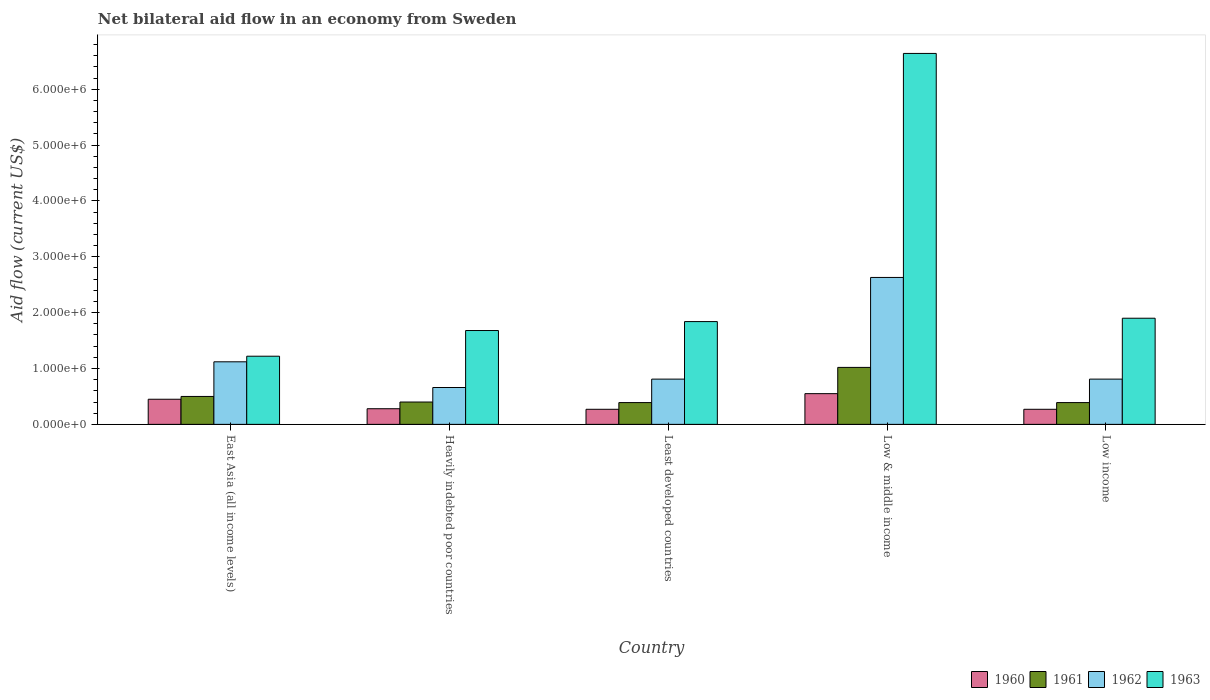How many different coloured bars are there?
Your answer should be very brief. 4. Are the number of bars on each tick of the X-axis equal?
Give a very brief answer. Yes. How many bars are there on the 1st tick from the right?
Your answer should be very brief. 4. What is the label of the 2nd group of bars from the left?
Your answer should be very brief. Heavily indebted poor countries. Across all countries, what is the maximum net bilateral aid flow in 1961?
Your answer should be compact. 1.02e+06. In which country was the net bilateral aid flow in 1962 maximum?
Ensure brevity in your answer.  Low & middle income. In which country was the net bilateral aid flow in 1961 minimum?
Provide a succinct answer. Least developed countries. What is the total net bilateral aid flow in 1963 in the graph?
Ensure brevity in your answer.  1.33e+07. What is the difference between the net bilateral aid flow in 1962 in Heavily indebted poor countries and the net bilateral aid flow in 1961 in Low & middle income?
Your answer should be very brief. -3.60e+05. What is the average net bilateral aid flow in 1961 per country?
Give a very brief answer. 5.40e+05. What is the difference between the net bilateral aid flow of/in 1963 and net bilateral aid flow of/in 1962 in East Asia (all income levels)?
Keep it short and to the point. 1.00e+05. In how many countries, is the net bilateral aid flow in 1961 greater than 2600000 US$?
Keep it short and to the point. 0. What is the ratio of the net bilateral aid flow in 1960 in Least developed countries to that in Low income?
Your answer should be compact. 1. Is the net bilateral aid flow in 1963 in Low & middle income less than that in Low income?
Make the answer very short. No. Is the difference between the net bilateral aid flow in 1963 in East Asia (all income levels) and Low income greater than the difference between the net bilateral aid flow in 1962 in East Asia (all income levels) and Low income?
Ensure brevity in your answer.  No. What is the difference between the highest and the lowest net bilateral aid flow in 1960?
Keep it short and to the point. 2.80e+05. In how many countries, is the net bilateral aid flow in 1963 greater than the average net bilateral aid flow in 1963 taken over all countries?
Provide a succinct answer. 1. Is it the case that in every country, the sum of the net bilateral aid flow in 1960 and net bilateral aid flow in 1961 is greater than the sum of net bilateral aid flow in 1962 and net bilateral aid flow in 1963?
Provide a succinct answer. No. What does the 4th bar from the left in Least developed countries represents?
Ensure brevity in your answer.  1963. What does the 3rd bar from the right in East Asia (all income levels) represents?
Your response must be concise. 1961. Is it the case that in every country, the sum of the net bilateral aid flow in 1962 and net bilateral aid flow in 1960 is greater than the net bilateral aid flow in 1961?
Keep it short and to the point. Yes. Are all the bars in the graph horizontal?
Offer a terse response. No. How many countries are there in the graph?
Keep it short and to the point. 5. Does the graph contain any zero values?
Your answer should be very brief. No. Does the graph contain grids?
Make the answer very short. No. Where does the legend appear in the graph?
Your answer should be very brief. Bottom right. How many legend labels are there?
Make the answer very short. 4. How are the legend labels stacked?
Your answer should be very brief. Horizontal. What is the title of the graph?
Keep it short and to the point. Net bilateral aid flow in an economy from Sweden. What is the label or title of the X-axis?
Give a very brief answer. Country. What is the Aid flow (current US$) in 1960 in East Asia (all income levels)?
Provide a short and direct response. 4.50e+05. What is the Aid flow (current US$) of 1962 in East Asia (all income levels)?
Your response must be concise. 1.12e+06. What is the Aid flow (current US$) of 1963 in East Asia (all income levels)?
Provide a short and direct response. 1.22e+06. What is the Aid flow (current US$) in 1960 in Heavily indebted poor countries?
Make the answer very short. 2.80e+05. What is the Aid flow (current US$) of 1962 in Heavily indebted poor countries?
Your answer should be very brief. 6.60e+05. What is the Aid flow (current US$) of 1963 in Heavily indebted poor countries?
Make the answer very short. 1.68e+06. What is the Aid flow (current US$) of 1960 in Least developed countries?
Give a very brief answer. 2.70e+05. What is the Aid flow (current US$) of 1961 in Least developed countries?
Provide a succinct answer. 3.90e+05. What is the Aid flow (current US$) in 1962 in Least developed countries?
Provide a succinct answer. 8.10e+05. What is the Aid flow (current US$) of 1963 in Least developed countries?
Ensure brevity in your answer.  1.84e+06. What is the Aid flow (current US$) in 1961 in Low & middle income?
Give a very brief answer. 1.02e+06. What is the Aid flow (current US$) in 1962 in Low & middle income?
Make the answer very short. 2.63e+06. What is the Aid flow (current US$) of 1963 in Low & middle income?
Provide a short and direct response. 6.64e+06. What is the Aid flow (current US$) of 1961 in Low income?
Offer a very short reply. 3.90e+05. What is the Aid flow (current US$) of 1962 in Low income?
Your response must be concise. 8.10e+05. What is the Aid flow (current US$) of 1963 in Low income?
Give a very brief answer. 1.90e+06. Across all countries, what is the maximum Aid flow (current US$) in 1960?
Keep it short and to the point. 5.50e+05. Across all countries, what is the maximum Aid flow (current US$) in 1961?
Keep it short and to the point. 1.02e+06. Across all countries, what is the maximum Aid flow (current US$) in 1962?
Keep it short and to the point. 2.63e+06. Across all countries, what is the maximum Aid flow (current US$) of 1963?
Your response must be concise. 6.64e+06. Across all countries, what is the minimum Aid flow (current US$) of 1960?
Your response must be concise. 2.70e+05. Across all countries, what is the minimum Aid flow (current US$) of 1962?
Your answer should be very brief. 6.60e+05. Across all countries, what is the minimum Aid flow (current US$) of 1963?
Give a very brief answer. 1.22e+06. What is the total Aid flow (current US$) in 1960 in the graph?
Provide a succinct answer. 1.82e+06. What is the total Aid flow (current US$) of 1961 in the graph?
Provide a short and direct response. 2.70e+06. What is the total Aid flow (current US$) in 1962 in the graph?
Your answer should be very brief. 6.03e+06. What is the total Aid flow (current US$) in 1963 in the graph?
Your answer should be very brief. 1.33e+07. What is the difference between the Aid flow (current US$) of 1960 in East Asia (all income levels) and that in Heavily indebted poor countries?
Provide a short and direct response. 1.70e+05. What is the difference between the Aid flow (current US$) in 1963 in East Asia (all income levels) and that in Heavily indebted poor countries?
Provide a short and direct response. -4.60e+05. What is the difference between the Aid flow (current US$) in 1960 in East Asia (all income levels) and that in Least developed countries?
Your response must be concise. 1.80e+05. What is the difference between the Aid flow (current US$) in 1963 in East Asia (all income levels) and that in Least developed countries?
Provide a succinct answer. -6.20e+05. What is the difference between the Aid flow (current US$) of 1960 in East Asia (all income levels) and that in Low & middle income?
Keep it short and to the point. -1.00e+05. What is the difference between the Aid flow (current US$) of 1961 in East Asia (all income levels) and that in Low & middle income?
Your answer should be very brief. -5.20e+05. What is the difference between the Aid flow (current US$) of 1962 in East Asia (all income levels) and that in Low & middle income?
Offer a very short reply. -1.51e+06. What is the difference between the Aid flow (current US$) in 1963 in East Asia (all income levels) and that in Low & middle income?
Provide a succinct answer. -5.42e+06. What is the difference between the Aid flow (current US$) in 1963 in East Asia (all income levels) and that in Low income?
Offer a terse response. -6.80e+05. What is the difference between the Aid flow (current US$) in 1960 in Heavily indebted poor countries and that in Least developed countries?
Make the answer very short. 10000. What is the difference between the Aid flow (current US$) in 1962 in Heavily indebted poor countries and that in Least developed countries?
Give a very brief answer. -1.50e+05. What is the difference between the Aid flow (current US$) in 1961 in Heavily indebted poor countries and that in Low & middle income?
Ensure brevity in your answer.  -6.20e+05. What is the difference between the Aid flow (current US$) of 1962 in Heavily indebted poor countries and that in Low & middle income?
Keep it short and to the point. -1.97e+06. What is the difference between the Aid flow (current US$) in 1963 in Heavily indebted poor countries and that in Low & middle income?
Ensure brevity in your answer.  -4.96e+06. What is the difference between the Aid flow (current US$) in 1960 in Heavily indebted poor countries and that in Low income?
Offer a terse response. 10000. What is the difference between the Aid flow (current US$) of 1960 in Least developed countries and that in Low & middle income?
Keep it short and to the point. -2.80e+05. What is the difference between the Aid flow (current US$) in 1961 in Least developed countries and that in Low & middle income?
Ensure brevity in your answer.  -6.30e+05. What is the difference between the Aid flow (current US$) in 1962 in Least developed countries and that in Low & middle income?
Provide a short and direct response. -1.82e+06. What is the difference between the Aid flow (current US$) of 1963 in Least developed countries and that in Low & middle income?
Offer a terse response. -4.80e+06. What is the difference between the Aid flow (current US$) of 1962 in Least developed countries and that in Low income?
Provide a succinct answer. 0. What is the difference between the Aid flow (current US$) of 1960 in Low & middle income and that in Low income?
Your response must be concise. 2.80e+05. What is the difference between the Aid flow (current US$) of 1961 in Low & middle income and that in Low income?
Your response must be concise. 6.30e+05. What is the difference between the Aid flow (current US$) of 1962 in Low & middle income and that in Low income?
Give a very brief answer. 1.82e+06. What is the difference between the Aid flow (current US$) of 1963 in Low & middle income and that in Low income?
Your response must be concise. 4.74e+06. What is the difference between the Aid flow (current US$) in 1960 in East Asia (all income levels) and the Aid flow (current US$) in 1963 in Heavily indebted poor countries?
Your answer should be compact. -1.23e+06. What is the difference between the Aid flow (current US$) of 1961 in East Asia (all income levels) and the Aid flow (current US$) of 1963 in Heavily indebted poor countries?
Keep it short and to the point. -1.18e+06. What is the difference between the Aid flow (current US$) in 1962 in East Asia (all income levels) and the Aid flow (current US$) in 1963 in Heavily indebted poor countries?
Give a very brief answer. -5.60e+05. What is the difference between the Aid flow (current US$) of 1960 in East Asia (all income levels) and the Aid flow (current US$) of 1961 in Least developed countries?
Your answer should be compact. 6.00e+04. What is the difference between the Aid flow (current US$) of 1960 in East Asia (all income levels) and the Aid flow (current US$) of 1962 in Least developed countries?
Your answer should be compact. -3.60e+05. What is the difference between the Aid flow (current US$) of 1960 in East Asia (all income levels) and the Aid flow (current US$) of 1963 in Least developed countries?
Provide a succinct answer. -1.39e+06. What is the difference between the Aid flow (current US$) in 1961 in East Asia (all income levels) and the Aid flow (current US$) in 1962 in Least developed countries?
Offer a very short reply. -3.10e+05. What is the difference between the Aid flow (current US$) in 1961 in East Asia (all income levels) and the Aid flow (current US$) in 1963 in Least developed countries?
Offer a very short reply. -1.34e+06. What is the difference between the Aid flow (current US$) in 1962 in East Asia (all income levels) and the Aid flow (current US$) in 1963 in Least developed countries?
Keep it short and to the point. -7.20e+05. What is the difference between the Aid flow (current US$) of 1960 in East Asia (all income levels) and the Aid flow (current US$) of 1961 in Low & middle income?
Make the answer very short. -5.70e+05. What is the difference between the Aid flow (current US$) in 1960 in East Asia (all income levels) and the Aid flow (current US$) in 1962 in Low & middle income?
Provide a succinct answer. -2.18e+06. What is the difference between the Aid flow (current US$) of 1960 in East Asia (all income levels) and the Aid flow (current US$) of 1963 in Low & middle income?
Offer a terse response. -6.19e+06. What is the difference between the Aid flow (current US$) in 1961 in East Asia (all income levels) and the Aid flow (current US$) in 1962 in Low & middle income?
Your response must be concise. -2.13e+06. What is the difference between the Aid flow (current US$) in 1961 in East Asia (all income levels) and the Aid flow (current US$) in 1963 in Low & middle income?
Give a very brief answer. -6.14e+06. What is the difference between the Aid flow (current US$) in 1962 in East Asia (all income levels) and the Aid flow (current US$) in 1963 in Low & middle income?
Your response must be concise. -5.52e+06. What is the difference between the Aid flow (current US$) of 1960 in East Asia (all income levels) and the Aid flow (current US$) of 1961 in Low income?
Make the answer very short. 6.00e+04. What is the difference between the Aid flow (current US$) in 1960 in East Asia (all income levels) and the Aid flow (current US$) in 1962 in Low income?
Give a very brief answer. -3.60e+05. What is the difference between the Aid flow (current US$) of 1960 in East Asia (all income levels) and the Aid flow (current US$) of 1963 in Low income?
Offer a very short reply. -1.45e+06. What is the difference between the Aid flow (current US$) of 1961 in East Asia (all income levels) and the Aid flow (current US$) of 1962 in Low income?
Provide a short and direct response. -3.10e+05. What is the difference between the Aid flow (current US$) in 1961 in East Asia (all income levels) and the Aid flow (current US$) in 1963 in Low income?
Provide a short and direct response. -1.40e+06. What is the difference between the Aid flow (current US$) of 1962 in East Asia (all income levels) and the Aid flow (current US$) of 1963 in Low income?
Your response must be concise. -7.80e+05. What is the difference between the Aid flow (current US$) of 1960 in Heavily indebted poor countries and the Aid flow (current US$) of 1961 in Least developed countries?
Your answer should be very brief. -1.10e+05. What is the difference between the Aid flow (current US$) of 1960 in Heavily indebted poor countries and the Aid flow (current US$) of 1962 in Least developed countries?
Your answer should be very brief. -5.30e+05. What is the difference between the Aid flow (current US$) of 1960 in Heavily indebted poor countries and the Aid flow (current US$) of 1963 in Least developed countries?
Provide a short and direct response. -1.56e+06. What is the difference between the Aid flow (current US$) of 1961 in Heavily indebted poor countries and the Aid flow (current US$) of 1962 in Least developed countries?
Ensure brevity in your answer.  -4.10e+05. What is the difference between the Aid flow (current US$) of 1961 in Heavily indebted poor countries and the Aid flow (current US$) of 1963 in Least developed countries?
Provide a short and direct response. -1.44e+06. What is the difference between the Aid flow (current US$) in 1962 in Heavily indebted poor countries and the Aid flow (current US$) in 1963 in Least developed countries?
Make the answer very short. -1.18e+06. What is the difference between the Aid flow (current US$) in 1960 in Heavily indebted poor countries and the Aid flow (current US$) in 1961 in Low & middle income?
Offer a very short reply. -7.40e+05. What is the difference between the Aid flow (current US$) in 1960 in Heavily indebted poor countries and the Aid flow (current US$) in 1962 in Low & middle income?
Give a very brief answer. -2.35e+06. What is the difference between the Aid flow (current US$) in 1960 in Heavily indebted poor countries and the Aid flow (current US$) in 1963 in Low & middle income?
Ensure brevity in your answer.  -6.36e+06. What is the difference between the Aid flow (current US$) of 1961 in Heavily indebted poor countries and the Aid flow (current US$) of 1962 in Low & middle income?
Offer a terse response. -2.23e+06. What is the difference between the Aid flow (current US$) of 1961 in Heavily indebted poor countries and the Aid flow (current US$) of 1963 in Low & middle income?
Ensure brevity in your answer.  -6.24e+06. What is the difference between the Aid flow (current US$) of 1962 in Heavily indebted poor countries and the Aid flow (current US$) of 1963 in Low & middle income?
Your answer should be very brief. -5.98e+06. What is the difference between the Aid flow (current US$) of 1960 in Heavily indebted poor countries and the Aid flow (current US$) of 1962 in Low income?
Your answer should be very brief. -5.30e+05. What is the difference between the Aid flow (current US$) of 1960 in Heavily indebted poor countries and the Aid flow (current US$) of 1963 in Low income?
Provide a succinct answer. -1.62e+06. What is the difference between the Aid flow (current US$) of 1961 in Heavily indebted poor countries and the Aid flow (current US$) of 1962 in Low income?
Give a very brief answer. -4.10e+05. What is the difference between the Aid flow (current US$) in 1961 in Heavily indebted poor countries and the Aid flow (current US$) in 1963 in Low income?
Offer a very short reply. -1.50e+06. What is the difference between the Aid flow (current US$) in 1962 in Heavily indebted poor countries and the Aid flow (current US$) in 1963 in Low income?
Your response must be concise. -1.24e+06. What is the difference between the Aid flow (current US$) of 1960 in Least developed countries and the Aid flow (current US$) of 1961 in Low & middle income?
Provide a succinct answer. -7.50e+05. What is the difference between the Aid flow (current US$) in 1960 in Least developed countries and the Aid flow (current US$) in 1962 in Low & middle income?
Your response must be concise. -2.36e+06. What is the difference between the Aid flow (current US$) in 1960 in Least developed countries and the Aid flow (current US$) in 1963 in Low & middle income?
Your response must be concise. -6.37e+06. What is the difference between the Aid flow (current US$) of 1961 in Least developed countries and the Aid flow (current US$) of 1962 in Low & middle income?
Ensure brevity in your answer.  -2.24e+06. What is the difference between the Aid flow (current US$) of 1961 in Least developed countries and the Aid flow (current US$) of 1963 in Low & middle income?
Your answer should be very brief. -6.25e+06. What is the difference between the Aid flow (current US$) in 1962 in Least developed countries and the Aid flow (current US$) in 1963 in Low & middle income?
Provide a succinct answer. -5.83e+06. What is the difference between the Aid flow (current US$) in 1960 in Least developed countries and the Aid flow (current US$) in 1961 in Low income?
Make the answer very short. -1.20e+05. What is the difference between the Aid flow (current US$) of 1960 in Least developed countries and the Aid flow (current US$) of 1962 in Low income?
Your response must be concise. -5.40e+05. What is the difference between the Aid flow (current US$) in 1960 in Least developed countries and the Aid flow (current US$) in 1963 in Low income?
Ensure brevity in your answer.  -1.63e+06. What is the difference between the Aid flow (current US$) of 1961 in Least developed countries and the Aid flow (current US$) of 1962 in Low income?
Your response must be concise. -4.20e+05. What is the difference between the Aid flow (current US$) in 1961 in Least developed countries and the Aid flow (current US$) in 1963 in Low income?
Your response must be concise. -1.51e+06. What is the difference between the Aid flow (current US$) in 1962 in Least developed countries and the Aid flow (current US$) in 1963 in Low income?
Offer a terse response. -1.09e+06. What is the difference between the Aid flow (current US$) in 1960 in Low & middle income and the Aid flow (current US$) in 1961 in Low income?
Offer a very short reply. 1.60e+05. What is the difference between the Aid flow (current US$) of 1960 in Low & middle income and the Aid flow (current US$) of 1962 in Low income?
Keep it short and to the point. -2.60e+05. What is the difference between the Aid flow (current US$) in 1960 in Low & middle income and the Aid flow (current US$) in 1963 in Low income?
Provide a succinct answer. -1.35e+06. What is the difference between the Aid flow (current US$) of 1961 in Low & middle income and the Aid flow (current US$) of 1962 in Low income?
Give a very brief answer. 2.10e+05. What is the difference between the Aid flow (current US$) in 1961 in Low & middle income and the Aid flow (current US$) in 1963 in Low income?
Your response must be concise. -8.80e+05. What is the difference between the Aid flow (current US$) in 1962 in Low & middle income and the Aid flow (current US$) in 1963 in Low income?
Ensure brevity in your answer.  7.30e+05. What is the average Aid flow (current US$) in 1960 per country?
Ensure brevity in your answer.  3.64e+05. What is the average Aid flow (current US$) in 1961 per country?
Offer a very short reply. 5.40e+05. What is the average Aid flow (current US$) of 1962 per country?
Keep it short and to the point. 1.21e+06. What is the average Aid flow (current US$) in 1963 per country?
Ensure brevity in your answer.  2.66e+06. What is the difference between the Aid flow (current US$) in 1960 and Aid flow (current US$) in 1961 in East Asia (all income levels)?
Your answer should be very brief. -5.00e+04. What is the difference between the Aid flow (current US$) in 1960 and Aid flow (current US$) in 1962 in East Asia (all income levels)?
Your response must be concise. -6.70e+05. What is the difference between the Aid flow (current US$) in 1960 and Aid flow (current US$) in 1963 in East Asia (all income levels)?
Your response must be concise. -7.70e+05. What is the difference between the Aid flow (current US$) in 1961 and Aid flow (current US$) in 1962 in East Asia (all income levels)?
Your response must be concise. -6.20e+05. What is the difference between the Aid flow (current US$) of 1961 and Aid flow (current US$) of 1963 in East Asia (all income levels)?
Offer a terse response. -7.20e+05. What is the difference between the Aid flow (current US$) of 1962 and Aid flow (current US$) of 1963 in East Asia (all income levels)?
Keep it short and to the point. -1.00e+05. What is the difference between the Aid flow (current US$) in 1960 and Aid flow (current US$) in 1962 in Heavily indebted poor countries?
Provide a succinct answer. -3.80e+05. What is the difference between the Aid flow (current US$) of 1960 and Aid flow (current US$) of 1963 in Heavily indebted poor countries?
Your response must be concise. -1.40e+06. What is the difference between the Aid flow (current US$) in 1961 and Aid flow (current US$) in 1963 in Heavily indebted poor countries?
Your answer should be very brief. -1.28e+06. What is the difference between the Aid flow (current US$) of 1962 and Aid flow (current US$) of 1963 in Heavily indebted poor countries?
Keep it short and to the point. -1.02e+06. What is the difference between the Aid flow (current US$) in 1960 and Aid flow (current US$) in 1961 in Least developed countries?
Offer a very short reply. -1.20e+05. What is the difference between the Aid flow (current US$) in 1960 and Aid flow (current US$) in 1962 in Least developed countries?
Ensure brevity in your answer.  -5.40e+05. What is the difference between the Aid flow (current US$) in 1960 and Aid flow (current US$) in 1963 in Least developed countries?
Your answer should be compact. -1.57e+06. What is the difference between the Aid flow (current US$) of 1961 and Aid flow (current US$) of 1962 in Least developed countries?
Offer a very short reply. -4.20e+05. What is the difference between the Aid flow (current US$) of 1961 and Aid flow (current US$) of 1963 in Least developed countries?
Keep it short and to the point. -1.45e+06. What is the difference between the Aid flow (current US$) in 1962 and Aid flow (current US$) in 1963 in Least developed countries?
Your answer should be very brief. -1.03e+06. What is the difference between the Aid flow (current US$) in 1960 and Aid flow (current US$) in 1961 in Low & middle income?
Your response must be concise. -4.70e+05. What is the difference between the Aid flow (current US$) of 1960 and Aid flow (current US$) of 1962 in Low & middle income?
Provide a succinct answer. -2.08e+06. What is the difference between the Aid flow (current US$) of 1960 and Aid flow (current US$) of 1963 in Low & middle income?
Provide a succinct answer. -6.09e+06. What is the difference between the Aid flow (current US$) in 1961 and Aid flow (current US$) in 1962 in Low & middle income?
Make the answer very short. -1.61e+06. What is the difference between the Aid flow (current US$) in 1961 and Aid flow (current US$) in 1963 in Low & middle income?
Provide a short and direct response. -5.62e+06. What is the difference between the Aid flow (current US$) in 1962 and Aid flow (current US$) in 1963 in Low & middle income?
Your answer should be compact. -4.01e+06. What is the difference between the Aid flow (current US$) in 1960 and Aid flow (current US$) in 1961 in Low income?
Your answer should be compact. -1.20e+05. What is the difference between the Aid flow (current US$) in 1960 and Aid flow (current US$) in 1962 in Low income?
Provide a short and direct response. -5.40e+05. What is the difference between the Aid flow (current US$) of 1960 and Aid flow (current US$) of 1963 in Low income?
Your response must be concise. -1.63e+06. What is the difference between the Aid flow (current US$) of 1961 and Aid flow (current US$) of 1962 in Low income?
Provide a short and direct response. -4.20e+05. What is the difference between the Aid flow (current US$) of 1961 and Aid flow (current US$) of 1963 in Low income?
Provide a short and direct response. -1.51e+06. What is the difference between the Aid flow (current US$) in 1962 and Aid flow (current US$) in 1963 in Low income?
Make the answer very short. -1.09e+06. What is the ratio of the Aid flow (current US$) in 1960 in East Asia (all income levels) to that in Heavily indebted poor countries?
Make the answer very short. 1.61. What is the ratio of the Aid flow (current US$) in 1961 in East Asia (all income levels) to that in Heavily indebted poor countries?
Your answer should be compact. 1.25. What is the ratio of the Aid flow (current US$) of 1962 in East Asia (all income levels) to that in Heavily indebted poor countries?
Give a very brief answer. 1.7. What is the ratio of the Aid flow (current US$) in 1963 in East Asia (all income levels) to that in Heavily indebted poor countries?
Make the answer very short. 0.73. What is the ratio of the Aid flow (current US$) in 1960 in East Asia (all income levels) to that in Least developed countries?
Your answer should be very brief. 1.67. What is the ratio of the Aid flow (current US$) in 1961 in East Asia (all income levels) to that in Least developed countries?
Provide a short and direct response. 1.28. What is the ratio of the Aid flow (current US$) of 1962 in East Asia (all income levels) to that in Least developed countries?
Keep it short and to the point. 1.38. What is the ratio of the Aid flow (current US$) of 1963 in East Asia (all income levels) to that in Least developed countries?
Your answer should be compact. 0.66. What is the ratio of the Aid flow (current US$) of 1960 in East Asia (all income levels) to that in Low & middle income?
Offer a terse response. 0.82. What is the ratio of the Aid flow (current US$) of 1961 in East Asia (all income levels) to that in Low & middle income?
Your answer should be compact. 0.49. What is the ratio of the Aid flow (current US$) of 1962 in East Asia (all income levels) to that in Low & middle income?
Your answer should be compact. 0.43. What is the ratio of the Aid flow (current US$) of 1963 in East Asia (all income levels) to that in Low & middle income?
Your response must be concise. 0.18. What is the ratio of the Aid flow (current US$) in 1960 in East Asia (all income levels) to that in Low income?
Provide a succinct answer. 1.67. What is the ratio of the Aid flow (current US$) in 1961 in East Asia (all income levels) to that in Low income?
Make the answer very short. 1.28. What is the ratio of the Aid flow (current US$) of 1962 in East Asia (all income levels) to that in Low income?
Make the answer very short. 1.38. What is the ratio of the Aid flow (current US$) in 1963 in East Asia (all income levels) to that in Low income?
Your answer should be very brief. 0.64. What is the ratio of the Aid flow (current US$) of 1961 in Heavily indebted poor countries to that in Least developed countries?
Make the answer very short. 1.03. What is the ratio of the Aid flow (current US$) in 1962 in Heavily indebted poor countries to that in Least developed countries?
Your response must be concise. 0.81. What is the ratio of the Aid flow (current US$) in 1963 in Heavily indebted poor countries to that in Least developed countries?
Offer a terse response. 0.91. What is the ratio of the Aid flow (current US$) of 1960 in Heavily indebted poor countries to that in Low & middle income?
Ensure brevity in your answer.  0.51. What is the ratio of the Aid flow (current US$) in 1961 in Heavily indebted poor countries to that in Low & middle income?
Give a very brief answer. 0.39. What is the ratio of the Aid flow (current US$) in 1962 in Heavily indebted poor countries to that in Low & middle income?
Ensure brevity in your answer.  0.25. What is the ratio of the Aid flow (current US$) of 1963 in Heavily indebted poor countries to that in Low & middle income?
Offer a terse response. 0.25. What is the ratio of the Aid flow (current US$) in 1961 in Heavily indebted poor countries to that in Low income?
Provide a succinct answer. 1.03. What is the ratio of the Aid flow (current US$) in 1962 in Heavily indebted poor countries to that in Low income?
Make the answer very short. 0.81. What is the ratio of the Aid flow (current US$) of 1963 in Heavily indebted poor countries to that in Low income?
Provide a succinct answer. 0.88. What is the ratio of the Aid flow (current US$) in 1960 in Least developed countries to that in Low & middle income?
Offer a terse response. 0.49. What is the ratio of the Aid flow (current US$) of 1961 in Least developed countries to that in Low & middle income?
Your answer should be very brief. 0.38. What is the ratio of the Aid flow (current US$) of 1962 in Least developed countries to that in Low & middle income?
Ensure brevity in your answer.  0.31. What is the ratio of the Aid flow (current US$) of 1963 in Least developed countries to that in Low & middle income?
Offer a very short reply. 0.28. What is the ratio of the Aid flow (current US$) in 1960 in Least developed countries to that in Low income?
Offer a terse response. 1. What is the ratio of the Aid flow (current US$) of 1962 in Least developed countries to that in Low income?
Your response must be concise. 1. What is the ratio of the Aid flow (current US$) of 1963 in Least developed countries to that in Low income?
Make the answer very short. 0.97. What is the ratio of the Aid flow (current US$) in 1960 in Low & middle income to that in Low income?
Make the answer very short. 2.04. What is the ratio of the Aid flow (current US$) in 1961 in Low & middle income to that in Low income?
Your answer should be very brief. 2.62. What is the ratio of the Aid flow (current US$) in 1962 in Low & middle income to that in Low income?
Offer a very short reply. 3.25. What is the ratio of the Aid flow (current US$) in 1963 in Low & middle income to that in Low income?
Make the answer very short. 3.49. What is the difference between the highest and the second highest Aid flow (current US$) of 1960?
Make the answer very short. 1.00e+05. What is the difference between the highest and the second highest Aid flow (current US$) in 1961?
Keep it short and to the point. 5.20e+05. What is the difference between the highest and the second highest Aid flow (current US$) of 1962?
Keep it short and to the point. 1.51e+06. What is the difference between the highest and the second highest Aid flow (current US$) of 1963?
Your answer should be very brief. 4.74e+06. What is the difference between the highest and the lowest Aid flow (current US$) of 1960?
Make the answer very short. 2.80e+05. What is the difference between the highest and the lowest Aid flow (current US$) in 1961?
Offer a terse response. 6.30e+05. What is the difference between the highest and the lowest Aid flow (current US$) in 1962?
Your answer should be compact. 1.97e+06. What is the difference between the highest and the lowest Aid flow (current US$) in 1963?
Offer a terse response. 5.42e+06. 